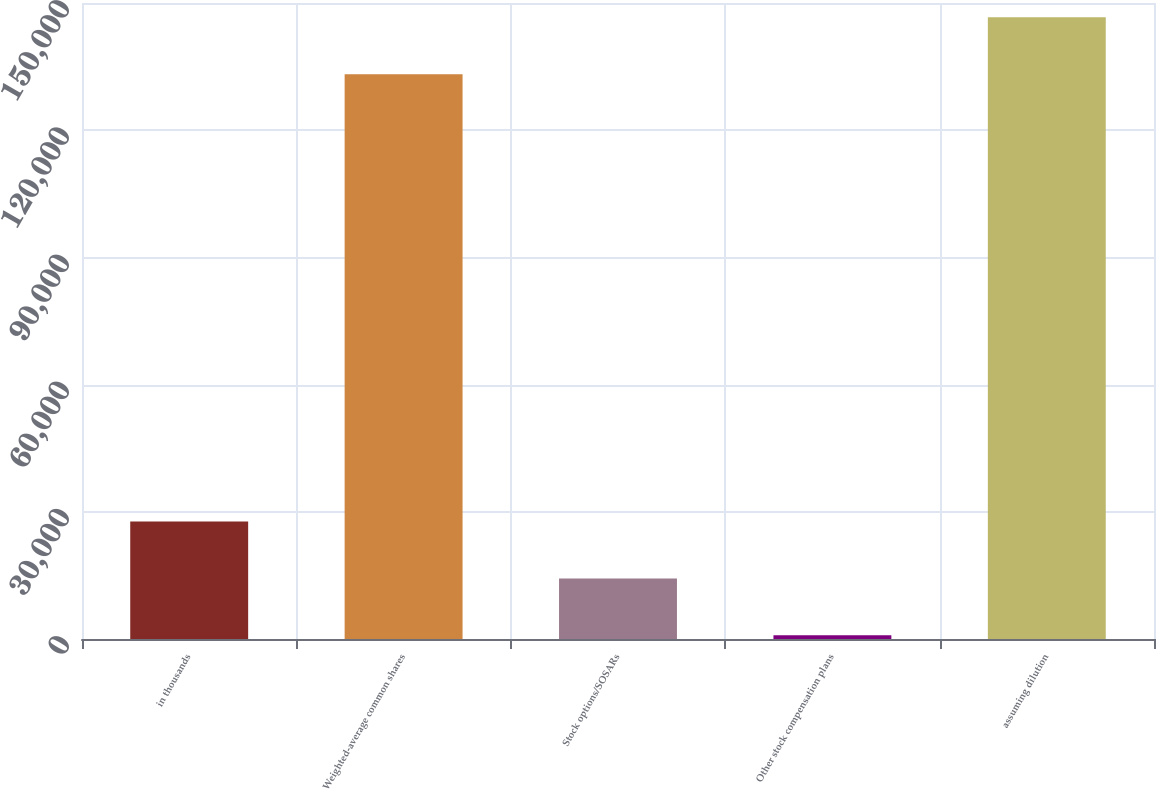Convert chart. <chart><loc_0><loc_0><loc_500><loc_500><bar_chart><fcel>in thousands<fcel>Weighted-average common shares<fcel>Stock options/SOSARs<fcel>Other stock compensation plans<fcel>assuming dilution<nl><fcel>27703.4<fcel>133210<fcel>14279.7<fcel>856<fcel>146634<nl></chart> 